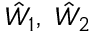Convert formula to latex. <formula><loc_0><loc_0><loc_500><loc_500>\hat { W } _ { 1 } , \hat { W } _ { 2 }</formula> 